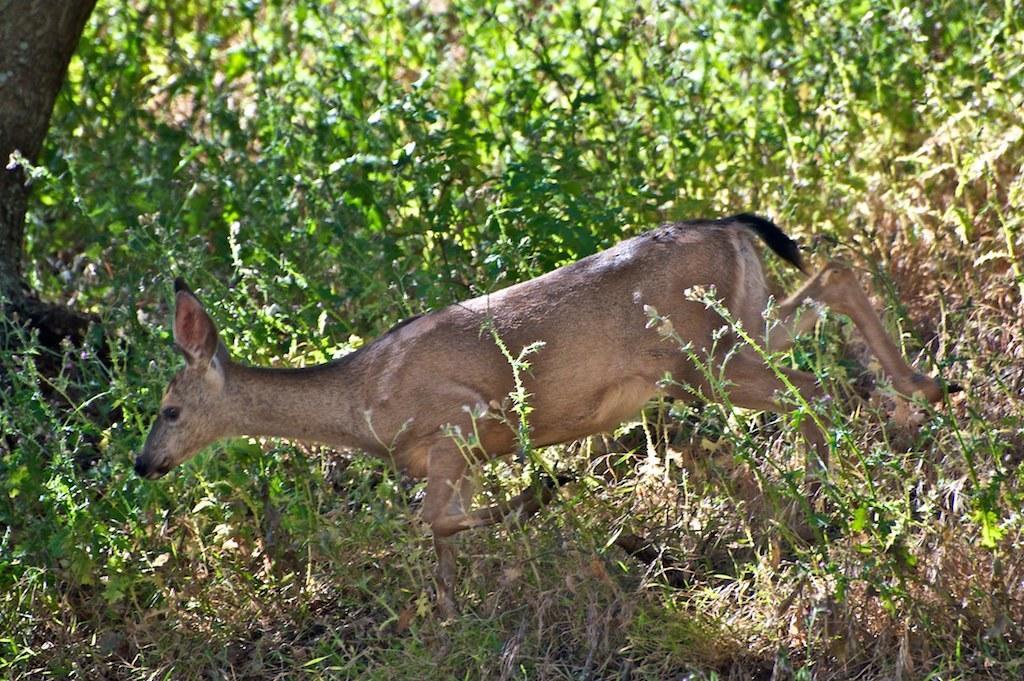Could you give a brief overview of what you see in this image? In this picture there is deer in the center of the image and there are plants around the area of the image. 